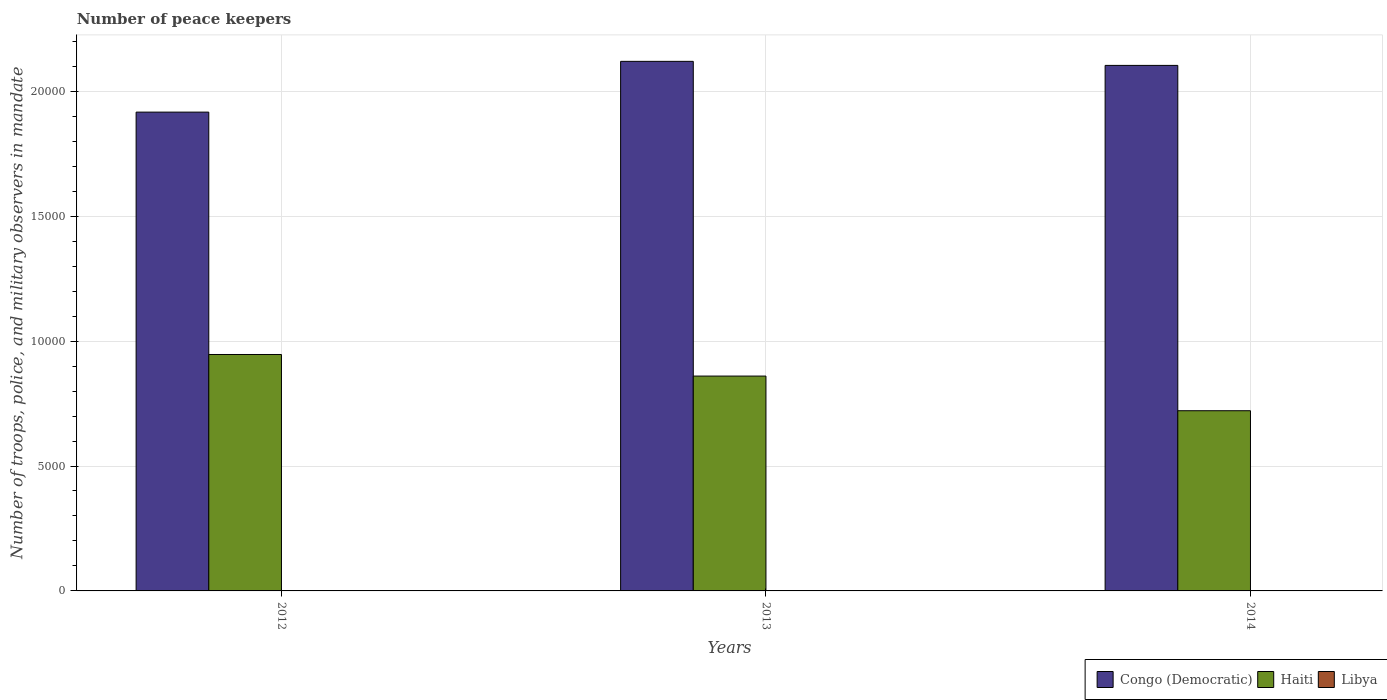How many groups of bars are there?
Your response must be concise. 3. Are the number of bars per tick equal to the number of legend labels?
Your answer should be very brief. Yes. Are the number of bars on each tick of the X-axis equal?
Provide a succinct answer. Yes. How many bars are there on the 1st tick from the left?
Make the answer very short. 3. What is the label of the 1st group of bars from the left?
Your answer should be very brief. 2012. What is the number of peace keepers in in Haiti in 2013?
Ensure brevity in your answer.  8600. Across all years, what is the minimum number of peace keepers in in Libya?
Offer a terse response. 2. In which year was the number of peace keepers in in Congo (Democratic) minimum?
Your response must be concise. 2012. What is the difference between the number of peace keepers in in Libya in 2012 and that in 2013?
Ensure brevity in your answer.  -9. What is the difference between the number of peace keepers in in Congo (Democratic) in 2014 and the number of peace keepers in in Libya in 2012?
Provide a short and direct response. 2.10e+04. What is the average number of peace keepers in in Haiti per year?
Offer a terse response. 8425.67. In the year 2012, what is the difference between the number of peace keepers in in Libya and number of peace keepers in in Haiti?
Keep it short and to the point. -9462. What is the ratio of the number of peace keepers in in Haiti in 2012 to that in 2013?
Ensure brevity in your answer.  1.1. What is the difference between the highest and the second highest number of peace keepers in in Haiti?
Offer a terse response. 864. What is the difference between the highest and the lowest number of peace keepers in in Haiti?
Keep it short and to the point. 2251. In how many years, is the number of peace keepers in in Libya greater than the average number of peace keepers in in Libya taken over all years?
Your answer should be very brief. 1. What does the 3rd bar from the left in 2012 represents?
Provide a succinct answer. Libya. What does the 1st bar from the right in 2013 represents?
Keep it short and to the point. Libya. How many bars are there?
Provide a succinct answer. 9. Are all the bars in the graph horizontal?
Give a very brief answer. No. How many years are there in the graph?
Provide a short and direct response. 3. Are the values on the major ticks of Y-axis written in scientific E-notation?
Provide a short and direct response. No. Does the graph contain grids?
Ensure brevity in your answer.  Yes. Where does the legend appear in the graph?
Offer a very short reply. Bottom right. What is the title of the graph?
Your response must be concise. Number of peace keepers. Does "Sub-Saharan Africa (developing only)" appear as one of the legend labels in the graph?
Make the answer very short. No. What is the label or title of the X-axis?
Your response must be concise. Years. What is the label or title of the Y-axis?
Offer a terse response. Number of troops, police, and military observers in mandate. What is the Number of troops, police, and military observers in mandate of Congo (Democratic) in 2012?
Offer a terse response. 1.92e+04. What is the Number of troops, police, and military observers in mandate in Haiti in 2012?
Provide a succinct answer. 9464. What is the Number of troops, police, and military observers in mandate of Libya in 2012?
Ensure brevity in your answer.  2. What is the Number of troops, police, and military observers in mandate in Congo (Democratic) in 2013?
Make the answer very short. 2.12e+04. What is the Number of troops, police, and military observers in mandate of Haiti in 2013?
Make the answer very short. 8600. What is the Number of troops, police, and military observers in mandate of Congo (Democratic) in 2014?
Ensure brevity in your answer.  2.10e+04. What is the Number of troops, police, and military observers in mandate of Haiti in 2014?
Provide a short and direct response. 7213. What is the Number of troops, police, and military observers in mandate of Libya in 2014?
Give a very brief answer. 2. Across all years, what is the maximum Number of troops, police, and military observers in mandate in Congo (Democratic)?
Provide a short and direct response. 2.12e+04. Across all years, what is the maximum Number of troops, police, and military observers in mandate in Haiti?
Your answer should be compact. 9464. Across all years, what is the minimum Number of troops, police, and military observers in mandate of Congo (Democratic)?
Make the answer very short. 1.92e+04. Across all years, what is the minimum Number of troops, police, and military observers in mandate in Haiti?
Offer a terse response. 7213. Across all years, what is the minimum Number of troops, police, and military observers in mandate of Libya?
Keep it short and to the point. 2. What is the total Number of troops, police, and military observers in mandate of Congo (Democratic) in the graph?
Your response must be concise. 6.14e+04. What is the total Number of troops, police, and military observers in mandate in Haiti in the graph?
Your response must be concise. 2.53e+04. What is the difference between the Number of troops, police, and military observers in mandate of Congo (Democratic) in 2012 and that in 2013?
Keep it short and to the point. -2032. What is the difference between the Number of troops, police, and military observers in mandate in Haiti in 2012 and that in 2013?
Make the answer very short. 864. What is the difference between the Number of troops, police, and military observers in mandate of Libya in 2012 and that in 2013?
Your response must be concise. -9. What is the difference between the Number of troops, police, and military observers in mandate of Congo (Democratic) in 2012 and that in 2014?
Your response must be concise. -1870. What is the difference between the Number of troops, police, and military observers in mandate in Haiti in 2012 and that in 2014?
Ensure brevity in your answer.  2251. What is the difference between the Number of troops, police, and military observers in mandate of Congo (Democratic) in 2013 and that in 2014?
Make the answer very short. 162. What is the difference between the Number of troops, police, and military observers in mandate in Haiti in 2013 and that in 2014?
Provide a succinct answer. 1387. What is the difference between the Number of troops, police, and military observers in mandate of Libya in 2013 and that in 2014?
Make the answer very short. 9. What is the difference between the Number of troops, police, and military observers in mandate in Congo (Democratic) in 2012 and the Number of troops, police, and military observers in mandate in Haiti in 2013?
Your answer should be compact. 1.06e+04. What is the difference between the Number of troops, police, and military observers in mandate of Congo (Democratic) in 2012 and the Number of troops, police, and military observers in mandate of Libya in 2013?
Ensure brevity in your answer.  1.92e+04. What is the difference between the Number of troops, police, and military observers in mandate of Haiti in 2012 and the Number of troops, police, and military observers in mandate of Libya in 2013?
Offer a very short reply. 9453. What is the difference between the Number of troops, police, and military observers in mandate of Congo (Democratic) in 2012 and the Number of troops, police, and military observers in mandate of Haiti in 2014?
Give a very brief answer. 1.20e+04. What is the difference between the Number of troops, police, and military observers in mandate in Congo (Democratic) in 2012 and the Number of troops, police, and military observers in mandate in Libya in 2014?
Your answer should be compact. 1.92e+04. What is the difference between the Number of troops, police, and military observers in mandate of Haiti in 2012 and the Number of troops, police, and military observers in mandate of Libya in 2014?
Ensure brevity in your answer.  9462. What is the difference between the Number of troops, police, and military observers in mandate of Congo (Democratic) in 2013 and the Number of troops, police, and military observers in mandate of Haiti in 2014?
Ensure brevity in your answer.  1.40e+04. What is the difference between the Number of troops, police, and military observers in mandate in Congo (Democratic) in 2013 and the Number of troops, police, and military observers in mandate in Libya in 2014?
Offer a very short reply. 2.12e+04. What is the difference between the Number of troops, police, and military observers in mandate in Haiti in 2013 and the Number of troops, police, and military observers in mandate in Libya in 2014?
Make the answer very short. 8598. What is the average Number of troops, police, and military observers in mandate of Congo (Democratic) per year?
Keep it short and to the point. 2.05e+04. What is the average Number of troops, police, and military observers in mandate of Haiti per year?
Your response must be concise. 8425.67. What is the average Number of troops, police, and military observers in mandate in Libya per year?
Provide a short and direct response. 5. In the year 2012, what is the difference between the Number of troops, police, and military observers in mandate of Congo (Democratic) and Number of troops, police, and military observers in mandate of Haiti?
Keep it short and to the point. 9702. In the year 2012, what is the difference between the Number of troops, police, and military observers in mandate in Congo (Democratic) and Number of troops, police, and military observers in mandate in Libya?
Offer a very short reply. 1.92e+04. In the year 2012, what is the difference between the Number of troops, police, and military observers in mandate in Haiti and Number of troops, police, and military observers in mandate in Libya?
Provide a short and direct response. 9462. In the year 2013, what is the difference between the Number of troops, police, and military observers in mandate in Congo (Democratic) and Number of troops, police, and military observers in mandate in Haiti?
Ensure brevity in your answer.  1.26e+04. In the year 2013, what is the difference between the Number of troops, police, and military observers in mandate in Congo (Democratic) and Number of troops, police, and military observers in mandate in Libya?
Ensure brevity in your answer.  2.12e+04. In the year 2013, what is the difference between the Number of troops, police, and military observers in mandate of Haiti and Number of troops, police, and military observers in mandate of Libya?
Offer a very short reply. 8589. In the year 2014, what is the difference between the Number of troops, police, and military observers in mandate in Congo (Democratic) and Number of troops, police, and military observers in mandate in Haiti?
Offer a terse response. 1.38e+04. In the year 2014, what is the difference between the Number of troops, police, and military observers in mandate of Congo (Democratic) and Number of troops, police, and military observers in mandate of Libya?
Provide a succinct answer. 2.10e+04. In the year 2014, what is the difference between the Number of troops, police, and military observers in mandate of Haiti and Number of troops, police, and military observers in mandate of Libya?
Keep it short and to the point. 7211. What is the ratio of the Number of troops, police, and military observers in mandate in Congo (Democratic) in 2012 to that in 2013?
Your response must be concise. 0.9. What is the ratio of the Number of troops, police, and military observers in mandate in Haiti in 2012 to that in 2013?
Provide a short and direct response. 1.1. What is the ratio of the Number of troops, police, and military observers in mandate of Libya in 2012 to that in 2013?
Keep it short and to the point. 0.18. What is the ratio of the Number of troops, police, and military observers in mandate in Congo (Democratic) in 2012 to that in 2014?
Your answer should be compact. 0.91. What is the ratio of the Number of troops, police, and military observers in mandate in Haiti in 2012 to that in 2014?
Provide a succinct answer. 1.31. What is the ratio of the Number of troops, police, and military observers in mandate in Libya in 2012 to that in 2014?
Your answer should be very brief. 1. What is the ratio of the Number of troops, police, and military observers in mandate of Congo (Democratic) in 2013 to that in 2014?
Make the answer very short. 1.01. What is the ratio of the Number of troops, police, and military observers in mandate in Haiti in 2013 to that in 2014?
Your answer should be compact. 1.19. What is the difference between the highest and the second highest Number of troops, police, and military observers in mandate of Congo (Democratic)?
Your answer should be very brief. 162. What is the difference between the highest and the second highest Number of troops, police, and military observers in mandate of Haiti?
Your response must be concise. 864. What is the difference between the highest and the lowest Number of troops, police, and military observers in mandate in Congo (Democratic)?
Keep it short and to the point. 2032. What is the difference between the highest and the lowest Number of troops, police, and military observers in mandate in Haiti?
Ensure brevity in your answer.  2251. What is the difference between the highest and the lowest Number of troops, police, and military observers in mandate of Libya?
Offer a very short reply. 9. 